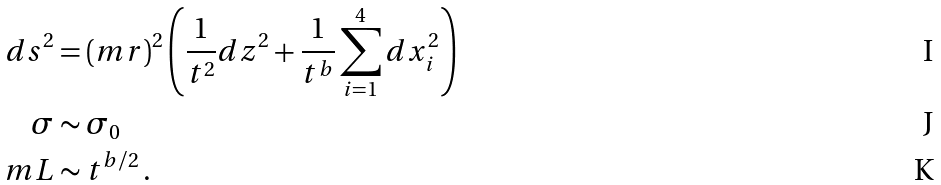<formula> <loc_0><loc_0><loc_500><loc_500>d s ^ { 2 } & = ( m r ) ^ { 2 } \left ( \frac { 1 } { t ^ { 2 } } d z ^ { 2 } + \frac { 1 } { t ^ { b } } \sum _ { i = 1 } ^ { 4 } d x _ { i } ^ { 2 } \right ) \\ \sigma & \sim \sigma _ { 0 } \\ m L & \sim t ^ { b / 2 } \, .</formula> 